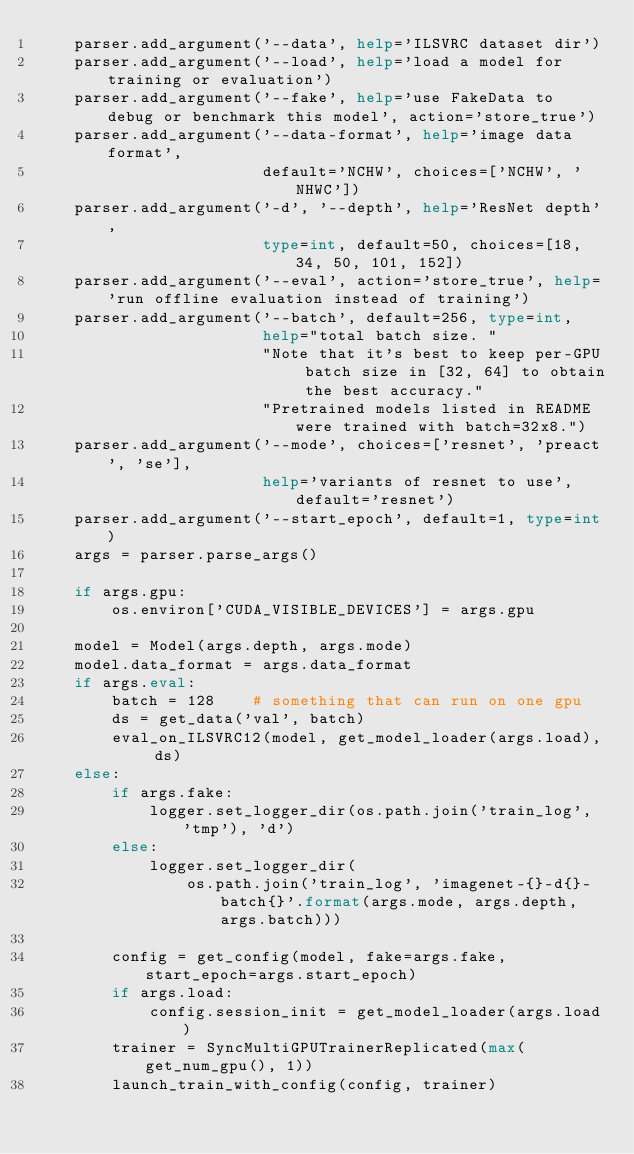Convert code to text. <code><loc_0><loc_0><loc_500><loc_500><_Python_>    parser.add_argument('--data', help='ILSVRC dataset dir')
    parser.add_argument('--load', help='load a model for training or evaluation')
    parser.add_argument('--fake', help='use FakeData to debug or benchmark this model', action='store_true')
    parser.add_argument('--data-format', help='image data format',
                        default='NCHW', choices=['NCHW', 'NHWC'])
    parser.add_argument('-d', '--depth', help='ResNet depth',
                        type=int, default=50, choices=[18, 34, 50, 101, 152])
    parser.add_argument('--eval', action='store_true', help='run offline evaluation instead of training')
    parser.add_argument('--batch', default=256, type=int,
                        help="total batch size. "
                        "Note that it's best to keep per-GPU batch size in [32, 64] to obtain the best accuracy."
                        "Pretrained models listed in README were trained with batch=32x8.")
    parser.add_argument('--mode', choices=['resnet', 'preact', 'se'],
                        help='variants of resnet to use', default='resnet')
    parser.add_argument('--start_epoch', default=1, type=int)
    args = parser.parse_args()

    if args.gpu:
        os.environ['CUDA_VISIBLE_DEVICES'] = args.gpu

    model = Model(args.depth, args.mode)
    model.data_format = args.data_format
    if args.eval:
        batch = 128    # something that can run on one gpu
        ds = get_data('val', batch)
        eval_on_ILSVRC12(model, get_model_loader(args.load), ds)
    else:
        if args.fake:
            logger.set_logger_dir(os.path.join('train_log', 'tmp'), 'd')
        else:
            logger.set_logger_dir(
                os.path.join('train_log', 'imagenet-{}-d{}-batch{}'.format(args.mode, args.depth, args.batch)))

        config = get_config(model, fake=args.fake, start_epoch=args.start_epoch)
        if args.load:
            config.session_init = get_model_loader(args.load)
        trainer = SyncMultiGPUTrainerReplicated(max(get_num_gpu(), 1))
        launch_train_with_config(config, trainer)
</code> 